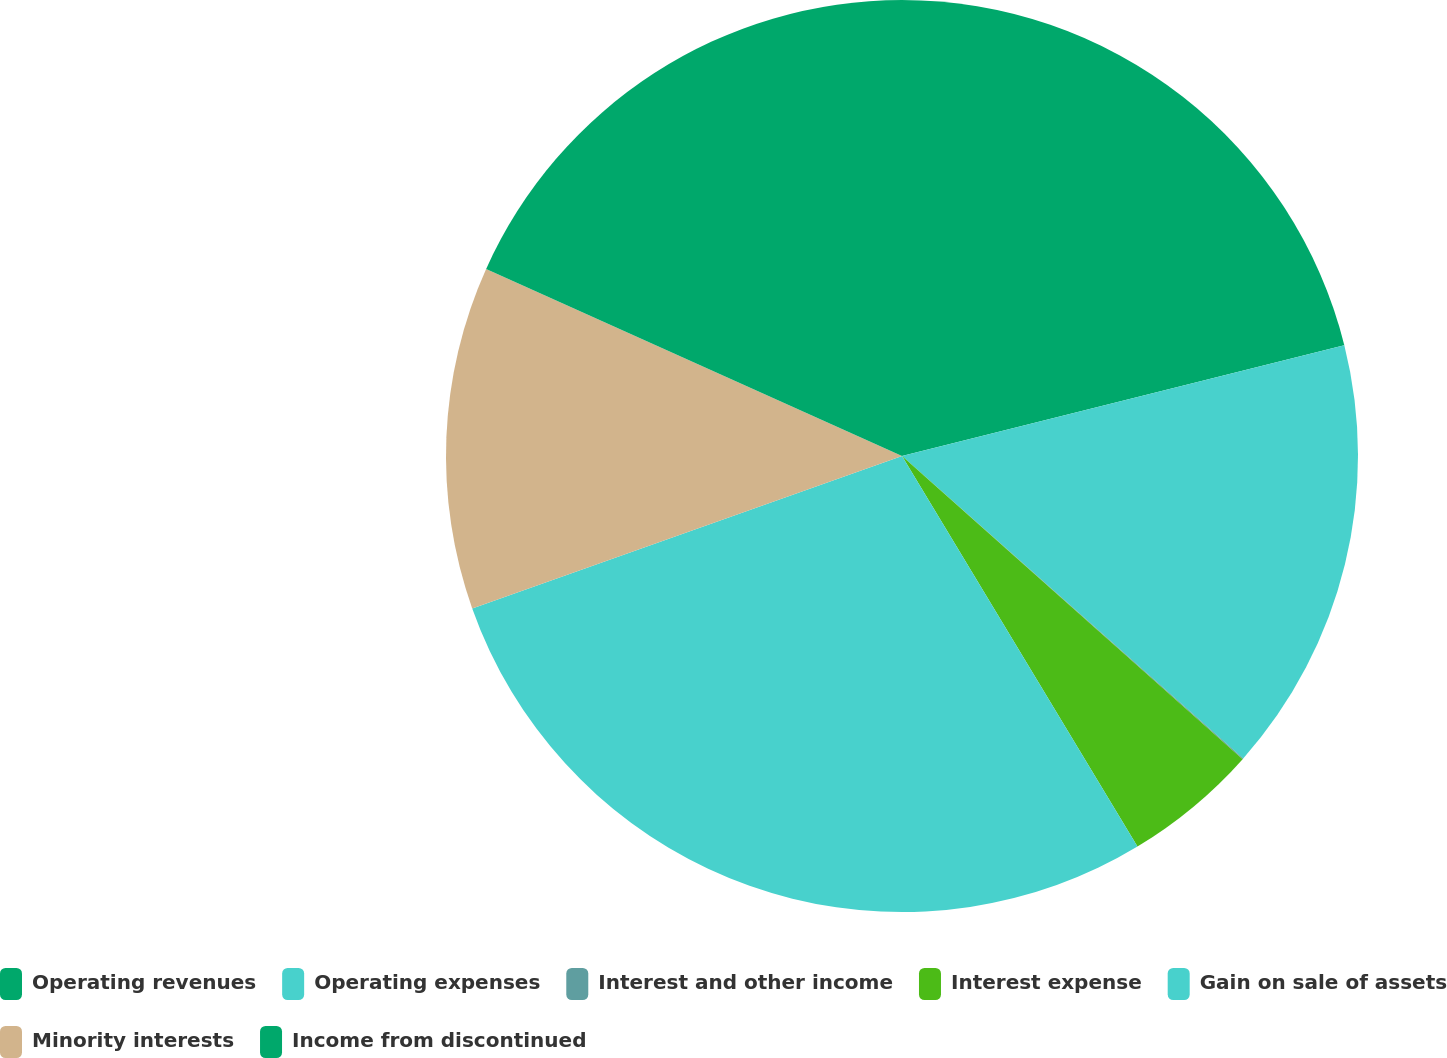<chart> <loc_0><loc_0><loc_500><loc_500><pie_chart><fcel>Operating revenues<fcel>Operating expenses<fcel>Interest and other income<fcel>Interest expense<fcel>Gain on sale of assets<fcel>Minority interests<fcel>Income from discontinued<nl><fcel>21.09%<fcel>15.45%<fcel>0.03%<fcel>4.79%<fcel>28.21%<fcel>12.15%<fcel>18.27%<nl></chart> 